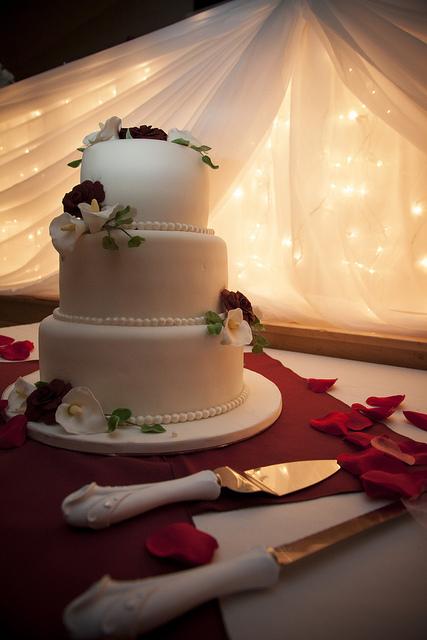What type of gem do the rings around each layer look like?
Give a very brief answer. Pearls. What event is this cake for?
Answer briefly. Wedding. How many utensils are in the table?
Keep it brief. 2. 